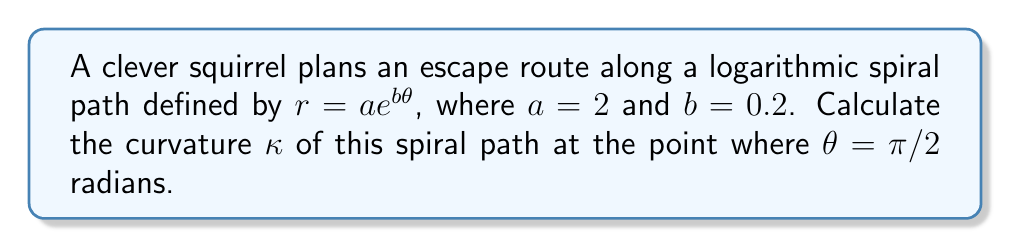What is the answer to this math problem? Let's approach this step-by-step:

1) The curvature of a plane curve in polar coordinates is given by:

   $$\kappa = \frac{|r^2 + 2(r')^2 - rr''|}{(r^2 + (r')^2)^{3/2}}$$

   where $r' = \frac{dr}{d\theta}$ and $r'' = \frac{d^2r}{d\theta^2}$.

2) For our logarithmic spiral, $r = ae^{b\theta}$, where $a = 2$ and $b = 0.2$.

3) Let's calculate $r'$ and $r''$:
   
   $r' = abe^{b\theta}$
   $r'' = ab^2e^{b\theta}$

4) Now, let's substitute these into our curvature formula:

   $$\kappa = \frac{|(ae^{b\theta})^2 + 2(abe^{b\theta})^2 - (ae^{b\theta})(ab^2e^{b\theta})|}{((ae^{b\theta})^2 + (abe^{b\theta})^2)^{3/2}}$$

5) Simplify:

   $$\kappa = \frac{|a^2e^{2b\theta}(1 + 2b^2 - b^2)|}{a^3e^{3b\theta}(1 + b^2)^{3/2}}$$

6) Further simplify:

   $$\kappa = \frac{|1 + b^2|}{ae^{b\theta}(1 + b^2)^{3/2}}$$

7) Now, let's substitute our values: $a = 2$, $b = 0.2$, and $\theta = \pi/2$:

   $$\kappa = \frac{|1 + 0.2^2|}{2e^{0.2(\pi/2)}(1 + 0.2^2)^{3/2}}$$

8) Calculate:

   $$\kappa \approx 0.3097$$
Answer: $\kappa \approx 0.3097$ 